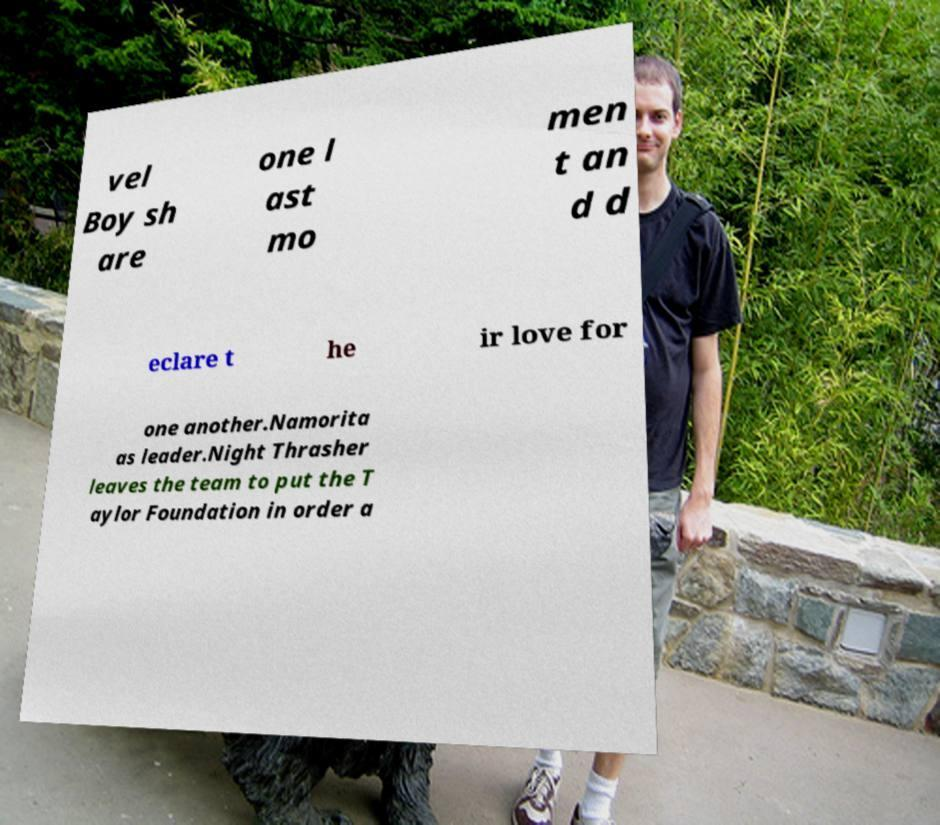There's text embedded in this image that I need extracted. Can you transcribe it verbatim? vel Boy sh are one l ast mo men t an d d eclare t he ir love for one another.Namorita as leader.Night Thrasher leaves the team to put the T aylor Foundation in order a 